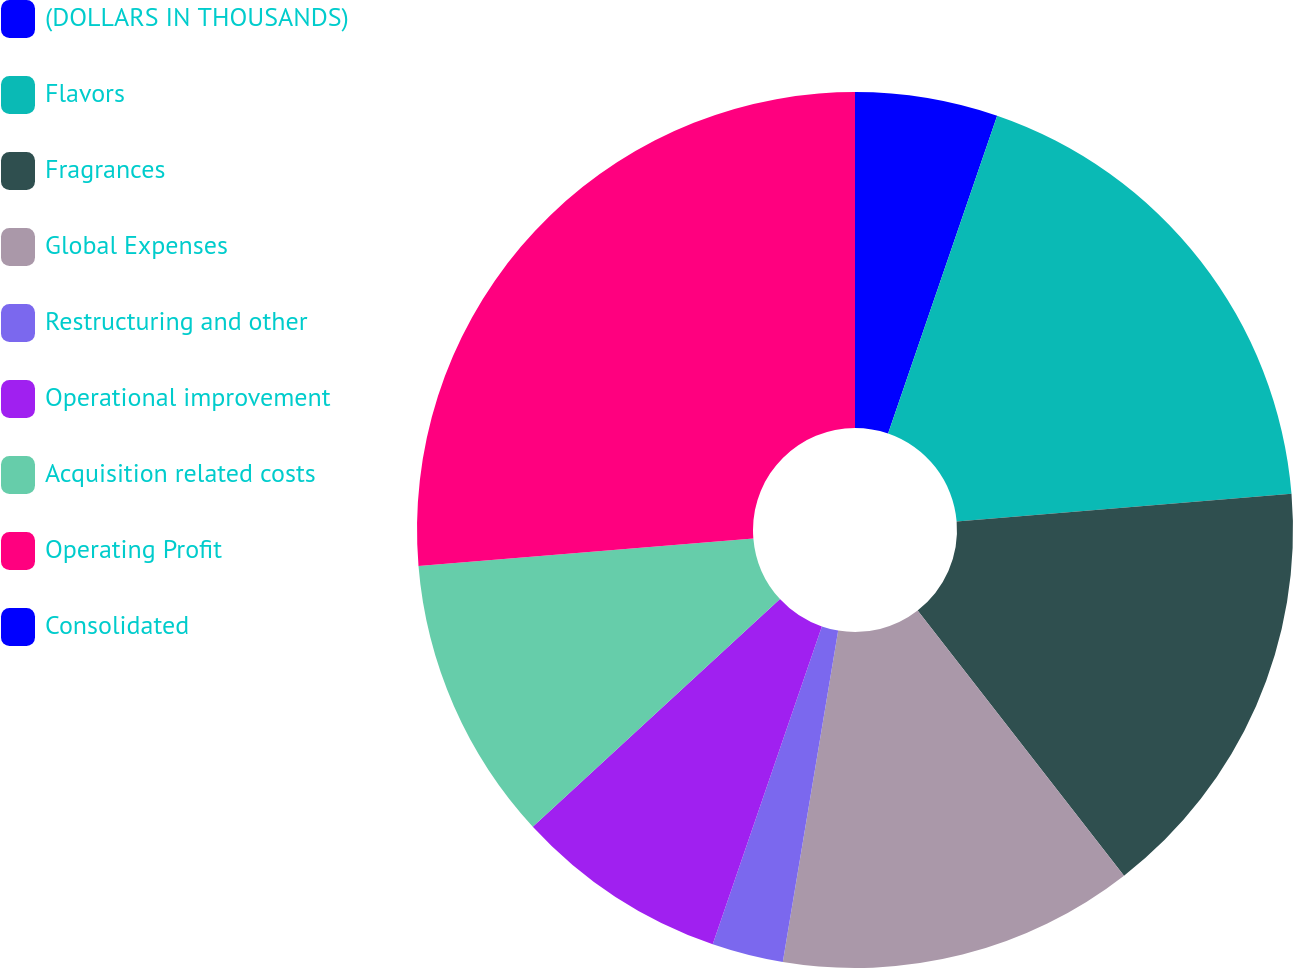Convert chart. <chart><loc_0><loc_0><loc_500><loc_500><pie_chart><fcel>(DOLLARS IN THOUSANDS)<fcel>Flavors<fcel>Fragrances<fcel>Global Expenses<fcel>Restructuring and other<fcel>Operational improvement<fcel>Acquisition related costs<fcel>Operating Profit<fcel>Consolidated<nl><fcel>5.26%<fcel>18.42%<fcel>15.79%<fcel>13.16%<fcel>2.63%<fcel>7.89%<fcel>10.53%<fcel>26.31%<fcel>0.0%<nl></chart> 